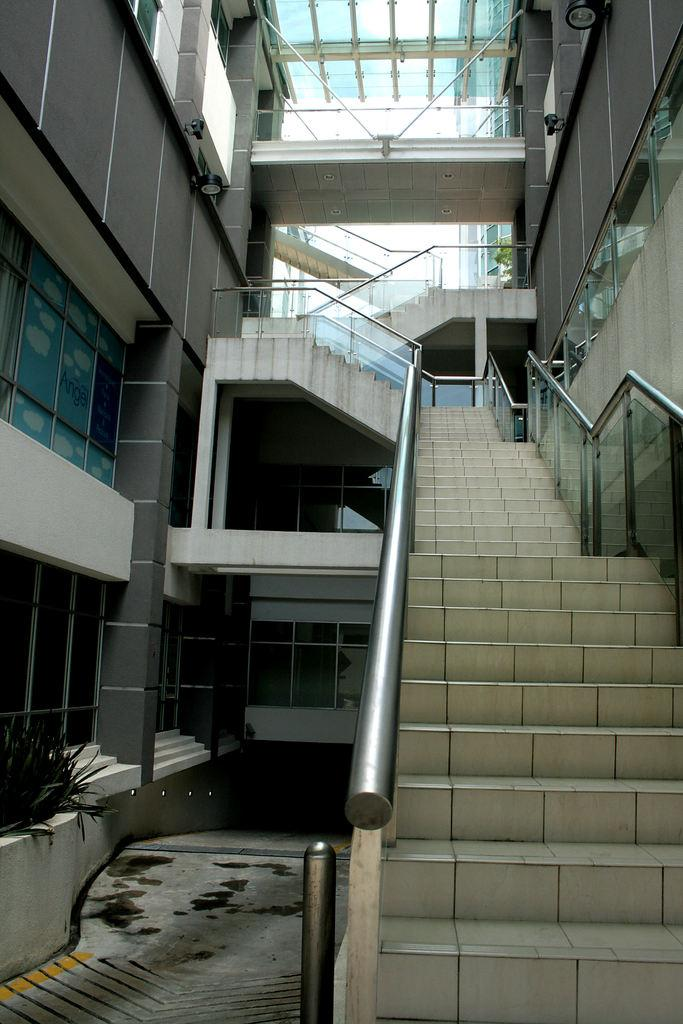What type of structure is visible in the image? There is a building in the image. What else can be seen in the image besides the building? There are rods in the image. What is the temperature of the ocean in the image? There is no ocean present in the image, so it is not possible to determine the temperature. 